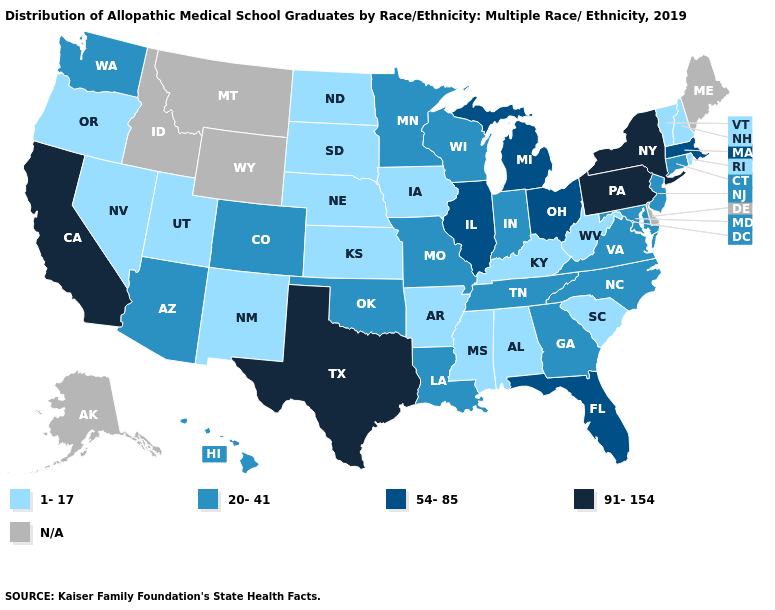Does Pennsylvania have the highest value in the USA?
Be succinct. Yes. Name the states that have a value in the range 20-41?
Concise answer only. Arizona, Colorado, Connecticut, Georgia, Hawaii, Indiana, Louisiana, Maryland, Minnesota, Missouri, New Jersey, North Carolina, Oklahoma, Tennessee, Virginia, Washington, Wisconsin. Name the states that have a value in the range 54-85?
Short answer required. Florida, Illinois, Massachusetts, Michigan, Ohio. Which states have the highest value in the USA?
Short answer required. California, New York, Pennsylvania, Texas. How many symbols are there in the legend?
Quick response, please. 5. Is the legend a continuous bar?
Give a very brief answer. No. Does the first symbol in the legend represent the smallest category?
Answer briefly. Yes. What is the lowest value in the USA?
Write a very short answer. 1-17. What is the highest value in the USA?
Write a very short answer. 91-154. What is the highest value in the USA?
Write a very short answer. 91-154. Does Alabama have the lowest value in the South?
Quick response, please. Yes. What is the value of Wisconsin?
Answer briefly. 20-41. Among the states that border North Dakota , does South Dakota have the lowest value?
Short answer required. Yes. Does New York have the highest value in the USA?
Write a very short answer. Yes. 